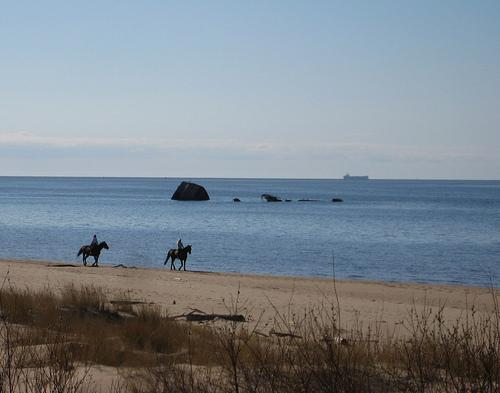Which actor has the training to do what these people are doing? Please explain your reasoning. russell crowe. Russell crowe rode a horse in the movie gladiator. 